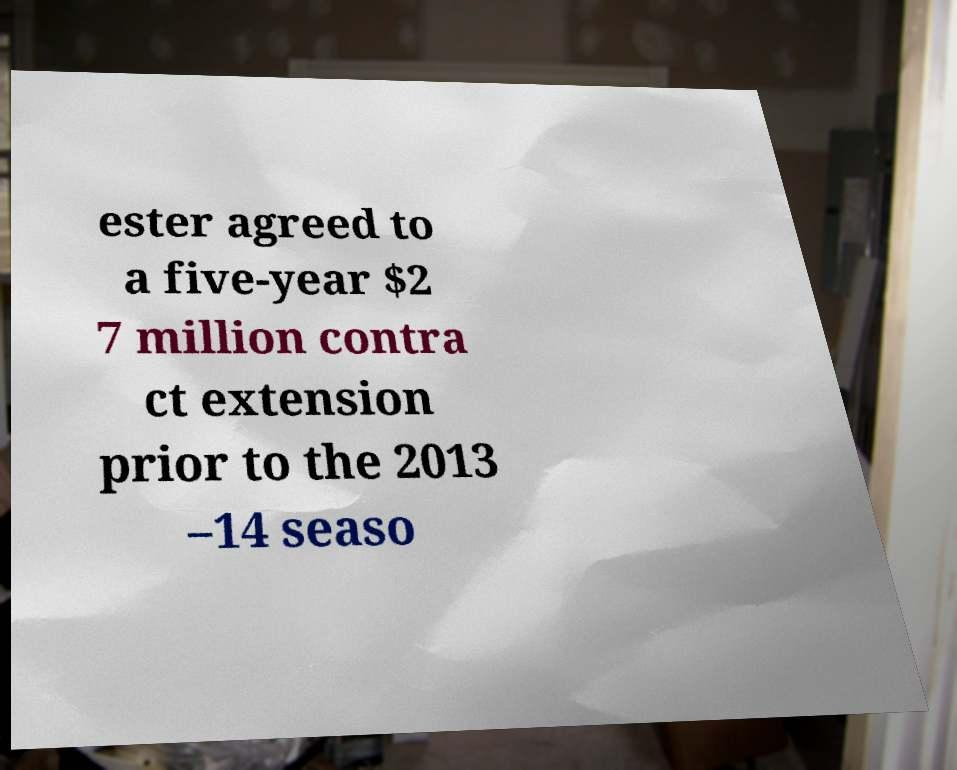Can you read and provide the text displayed in the image?This photo seems to have some interesting text. Can you extract and type it out for me? ester agreed to a five-year $2 7 million contra ct extension prior to the 2013 –14 seaso 